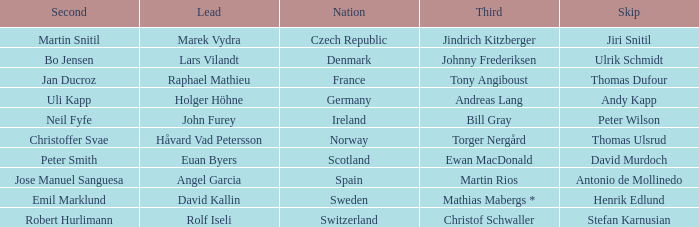When did France come in second? Jan Ducroz. 